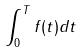<formula> <loc_0><loc_0><loc_500><loc_500>\int _ { 0 } ^ { T } f ( t ) d t</formula> 